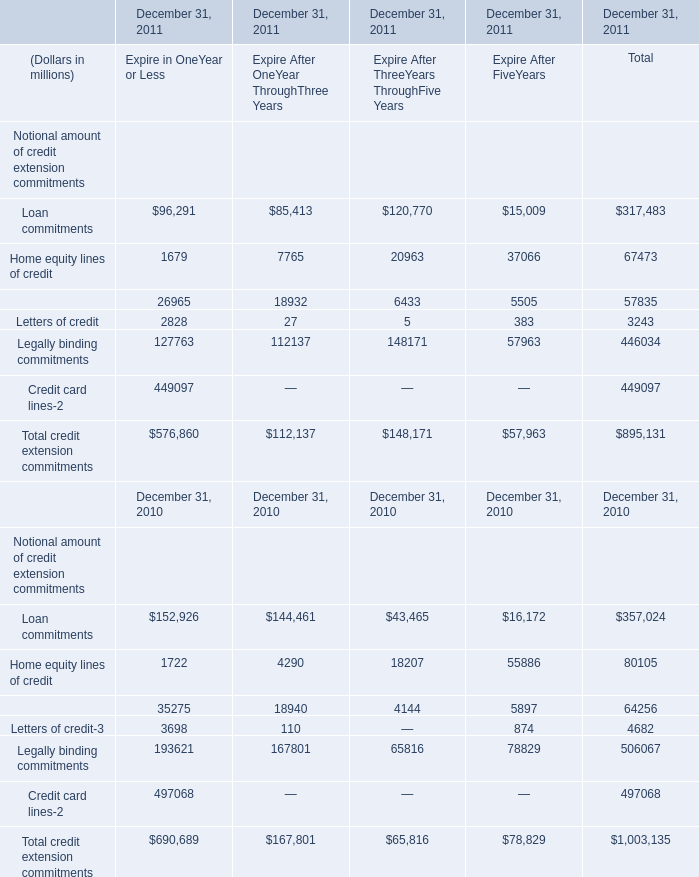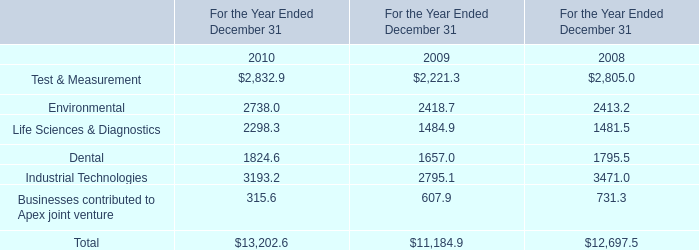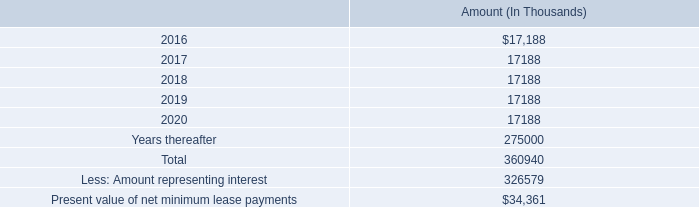what's the total amount of Industrial Technologies of For the Year Ended December 31 2009, and Loan commitments of December 31, 2011 Expire After FiveYears ? 
Computations: (2795.1 + 15009.0)
Answer: 17804.1. 